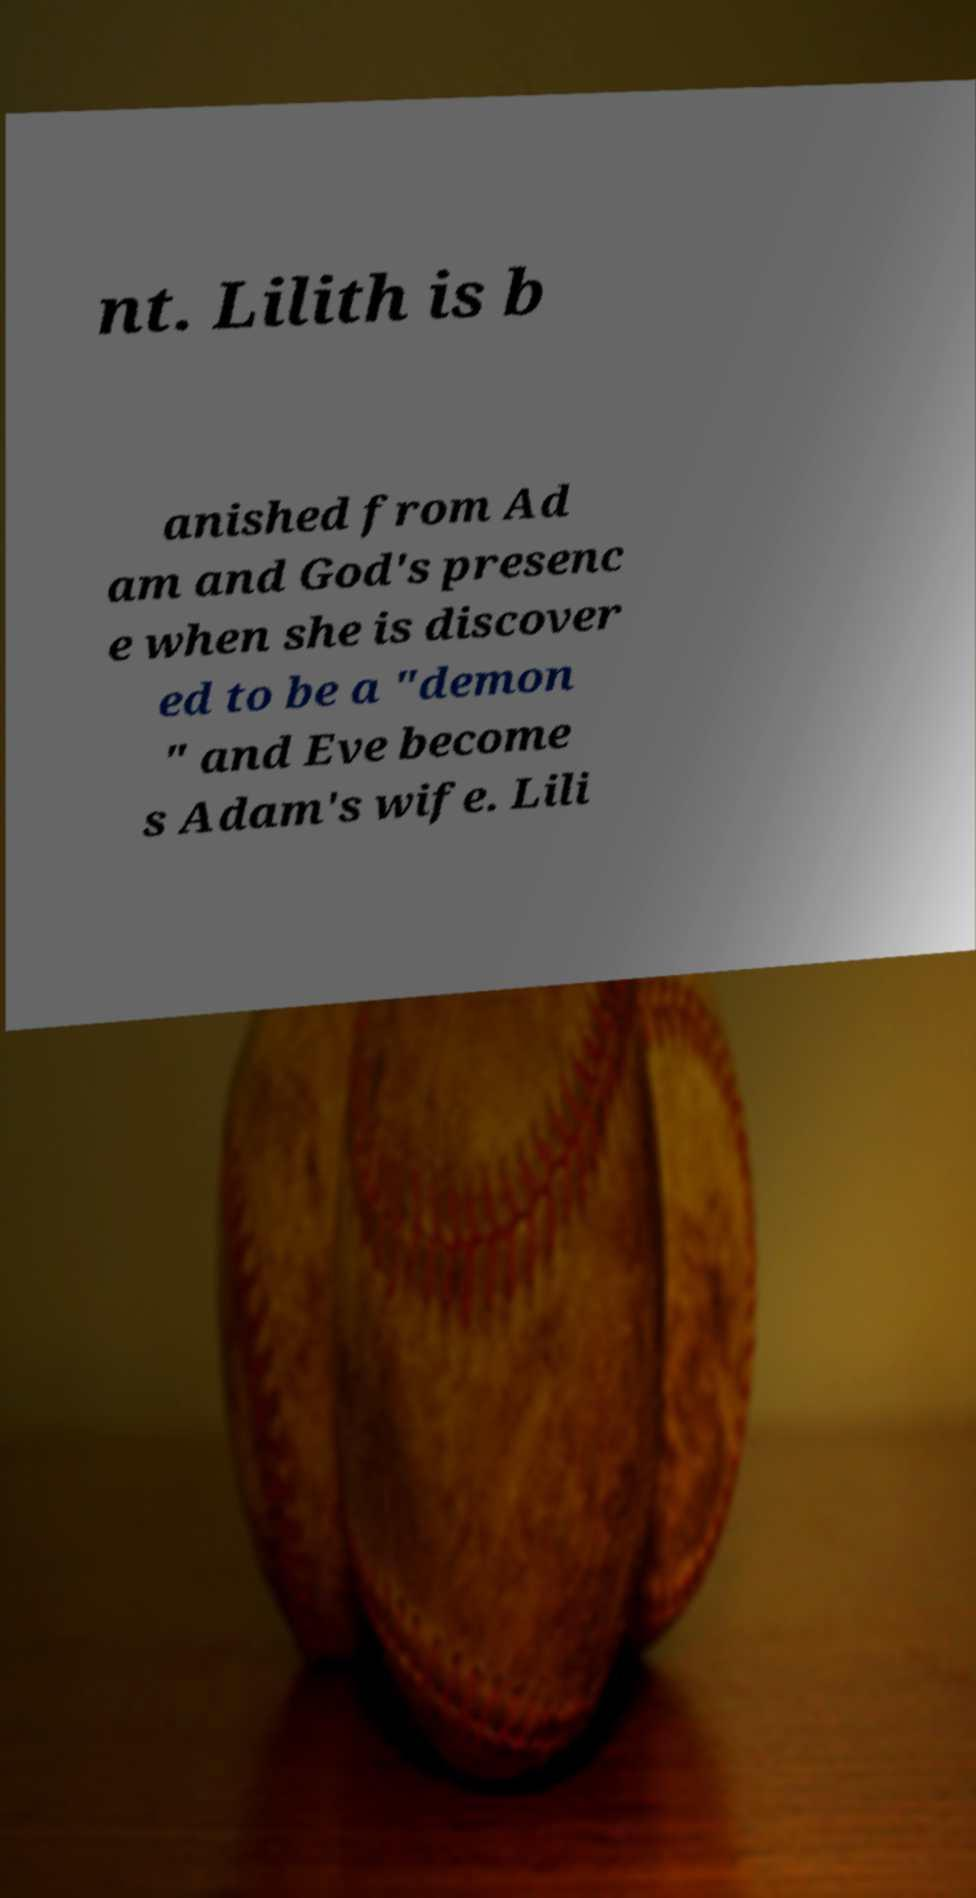There's text embedded in this image that I need extracted. Can you transcribe it verbatim? nt. Lilith is b anished from Ad am and God's presenc e when she is discover ed to be a "demon " and Eve become s Adam's wife. Lili 